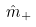Convert formula to latex. <formula><loc_0><loc_0><loc_500><loc_500>\hat { m } _ { + }</formula> 